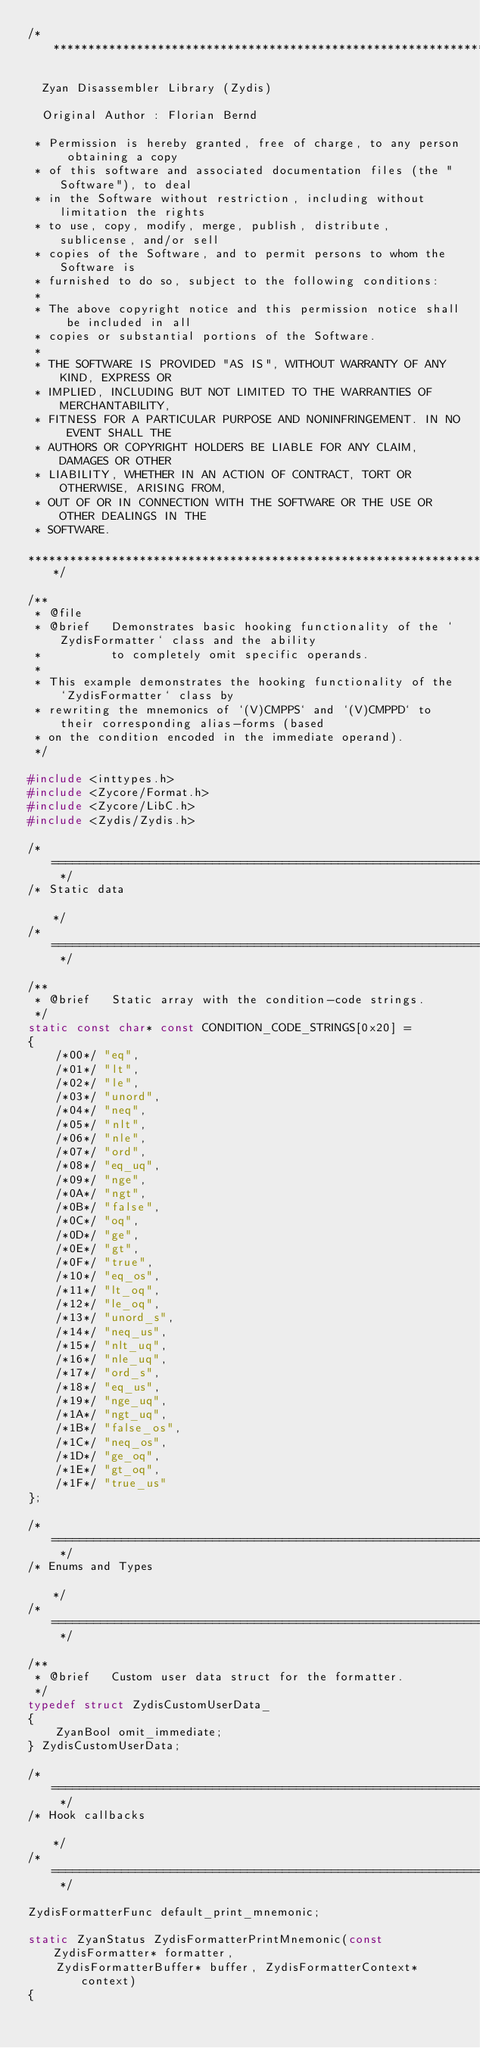Convert code to text. <code><loc_0><loc_0><loc_500><loc_500><_C_>/***************************************************************************************************

  Zyan Disassembler Library (Zydis)

  Original Author : Florian Bernd

 * Permission is hereby granted, free of charge, to any person obtaining a copy
 * of this software and associated documentation files (the "Software"), to deal
 * in the Software without restriction, including without limitation the rights
 * to use, copy, modify, merge, publish, distribute, sublicense, and/or sell
 * copies of the Software, and to permit persons to whom the Software is
 * furnished to do so, subject to the following conditions:
 *
 * The above copyright notice and this permission notice shall be included in all
 * copies or substantial portions of the Software.
 *
 * THE SOFTWARE IS PROVIDED "AS IS", WITHOUT WARRANTY OF ANY KIND, EXPRESS OR
 * IMPLIED, INCLUDING BUT NOT LIMITED TO THE WARRANTIES OF MERCHANTABILITY,
 * FITNESS FOR A PARTICULAR PURPOSE AND NONINFRINGEMENT. IN NO EVENT SHALL THE
 * AUTHORS OR COPYRIGHT HOLDERS BE LIABLE FOR ANY CLAIM, DAMAGES OR OTHER
 * LIABILITY, WHETHER IN AN ACTION OF CONTRACT, TORT OR OTHERWISE, ARISING FROM,
 * OUT OF OR IN CONNECTION WITH THE SOFTWARE OR THE USE OR OTHER DEALINGS IN THE
 * SOFTWARE.

***************************************************************************************************/

/**
 * @file
 * @brief   Demonstrates basic hooking functionality of the `ZydisFormatter` class and the ability
 *          to completely omit specific operands.
 *
 * This example demonstrates the hooking functionality of the `ZydisFormatter` class by
 * rewriting the mnemonics of `(V)CMPPS` and `(V)CMPPD` to their corresponding alias-forms (based
 * on the condition encoded in the immediate operand).
 */

#include <inttypes.h>
#include <Zycore/Format.h>
#include <Zycore/LibC.h>
#include <Zydis/Zydis.h>

/* ============================================================================================== */
/* Static data                                                                                    */
/* ============================================================================================== */

/**
 * @brief   Static array with the condition-code strings.
 */
static const char* const CONDITION_CODE_STRINGS[0x20] =
{
    /*00*/ "eq",
    /*01*/ "lt",
    /*02*/ "le",
    /*03*/ "unord",
    /*04*/ "neq",
    /*05*/ "nlt",
    /*06*/ "nle",
    /*07*/ "ord",
    /*08*/ "eq_uq",
    /*09*/ "nge",
    /*0A*/ "ngt",
    /*0B*/ "false",
    /*0C*/ "oq",
    /*0D*/ "ge",
    /*0E*/ "gt",
    /*0F*/ "true",
    /*10*/ "eq_os",
    /*11*/ "lt_oq",
    /*12*/ "le_oq",
    /*13*/ "unord_s",
    /*14*/ "neq_us",
    /*15*/ "nlt_uq",
    /*16*/ "nle_uq",
    /*17*/ "ord_s",
    /*18*/ "eq_us",
    /*19*/ "nge_uq",
    /*1A*/ "ngt_uq",
    /*1B*/ "false_os",
    /*1C*/ "neq_os",
    /*1D*/ "ge_oq",
    /*1E*/ "gt_oq",
    /*1F*/ "true_us"
};

/* ============================================================================================== */
/* Enums and Types                                                                                */
/* ============================================================================================== */

/**
 * @brief   Custom user data struct for the formatter.
 */
typedef struct ZydisCustomUserData_
{
    ZyanBool omit_immediate;
} ZydisCustomUserData;

/* ============================================================================================== */
/* Hook callbacks                                                                                 */
/* ============================================================================================== */

ZydisFormatterFunc default_print_mnemonic;

static ZyanStatus ZydisFormatterPrintMnemonic(const ZydisFormatter* formatter,
    ZydisFormatterBuffer* buffer, ZydisFormatterContext* context)
{</code> 